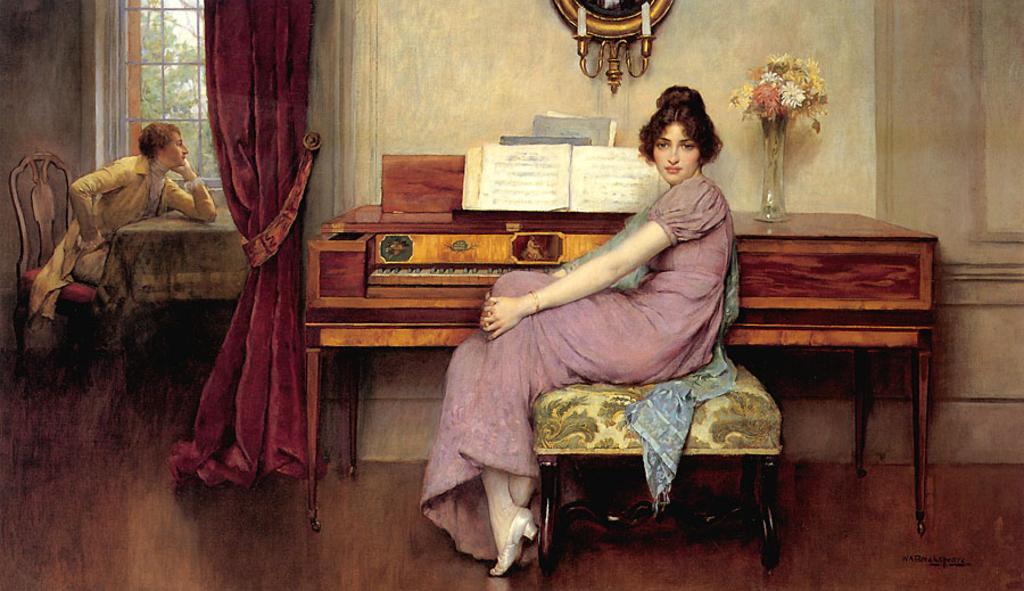In one or two sentences, can you explain what this image depicts? This is a painting. Here a woman is sitting on a stool. In the back of her there is a organ. Above that there is a book and a vase with flowers. On the wall there is a photo frame with candles and stand. On the left side there is a curtain. Another person is sitting on a chair. And there is a table in front of him. In the background there is a window and a wall. 